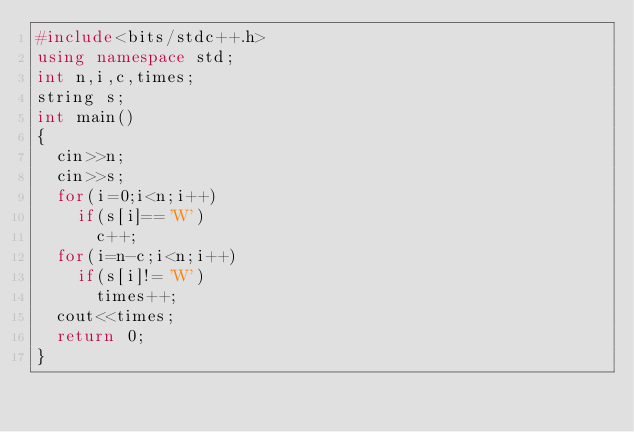Convert code to text. <code><loc_0><loc_0><loc_500><loc_500><_C++_>#include<bits/stdc++.h>
using namespace std;
int n,i,c,times;
string s;
int main()
{
	cin>>n;
	cin>>s;
	for(i=0;i<n;i++)
		if(s[i]=='W')
			c++;
	for(i=n-c;i<n;i++)
		if(s[i]!='W')
			times++;
	cout<<times;
	return 0;
}</code> 